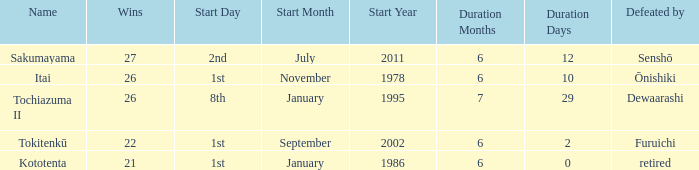Which duration was defeated by retired? 6 months 0 days. 